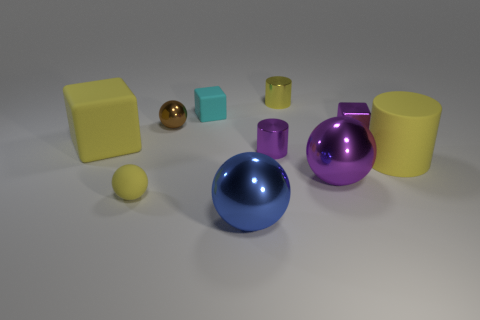Are there any other metallic balls of the same size as the yellow sphere?
Offer a terse response. Yes. Is the color of the rubber sphere that is behind the large blue metallic object the same as the tiny block that is behind the small purple cube?
Provide a succinct answer. No. Are there any other blocks of the same color as the tiny shiny block?
Offer a very short reply. No. What number of other things are the same shape as the large purple object?
Provide a succinct answer. 3. What is the shape of the yellow matte thing that is in front of the big purple thing?
Ensure brevity in your answer.  Sphere. Do the large purple metallic object and the tiny purple metallic object that is on the right side of the purple sphere have the same shape?
Your response must be concise. No. There is a rubber object that is both to the left of the small yellow shiny cylinder and to the right of the tiny yellow rubber thing; what is its size?
Provide a succinct answer. Small. What color is the thing that is both behind the large cylinder and right of the purple ball?
Provide a short and direct response. Purple. Are there any other things that are the same material as the yellow cube?
Your response must be concise. Yes. Is the number of small balls that are on the right side of the yellow matte cylinder less than the number of cylinders on the left side of the brown ball?
Keep it short and to the point. No. 